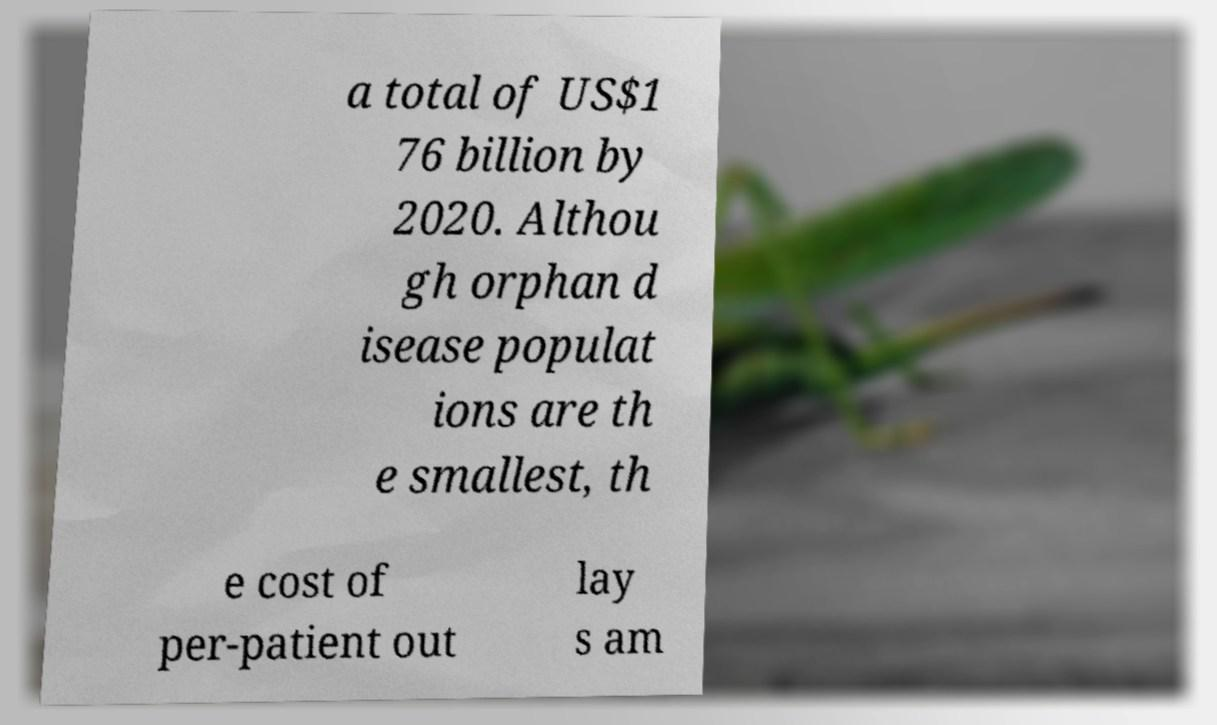For documentation purposes, I need the text within this image transcribed. Could you provide that? a total of US$1 76 billion by 2020. Althou gh orphan d isease populat ions are th e smallest, th e cost of per-patient out lay s am 